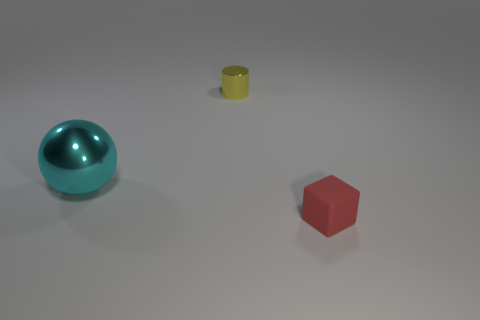Add 1 tiny blocks. How many objects exist? 4 Subtract all cubes. How many objects are left? 2 Add 3 small matte blocks. How many small matte blocks exist? 4 Subtract 0 gray spheres. How many objects are left? 3 Subtract all large metallic objects. Subtract all cyan things. How many objects are left? 1 Add 3 small red objects. How many small red objects are left? 4 